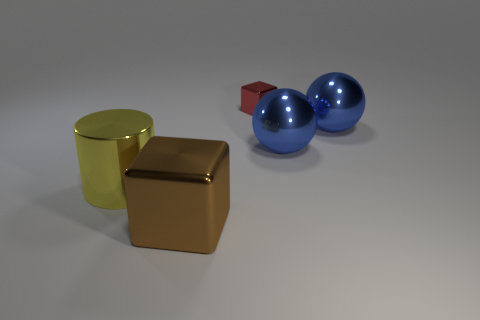How many large objects are metallic things or yellow cylinders?
Offer a very short reply. 4. How many other things are the same color as the big cylinder?
Offer a very short reply. 0. How many gray objects are shiny objects or small cubes?
Ensure brevity in your answer.  0. Is the shape of the small red metallic thing the same as the metallic thing that is in front of the yellow metallic object?
Ensure brevity in your answer.  Yes. What is the shape of the large yellow object?
Keep it short and to the point. Cylinder. Is there anything else that has the same size as the red block?
Make the answer very short. No. What number of things are tiny purple matte spheres or blocks that are to the right of the brown cube?
Ensure brevity in your answer.  1. What size is the red object that is the same material as the big yellow cylinder?
Offer a terse response. Small. There is a red metallic object that is behind the big object in front of the large metal cylinder; what shape is it?
Your answer should be compact. Cube. There is a shiny object that is on the left side of the red shiny cube and behind the brown object; what is its size?
Provide a succinct answer. Large. 